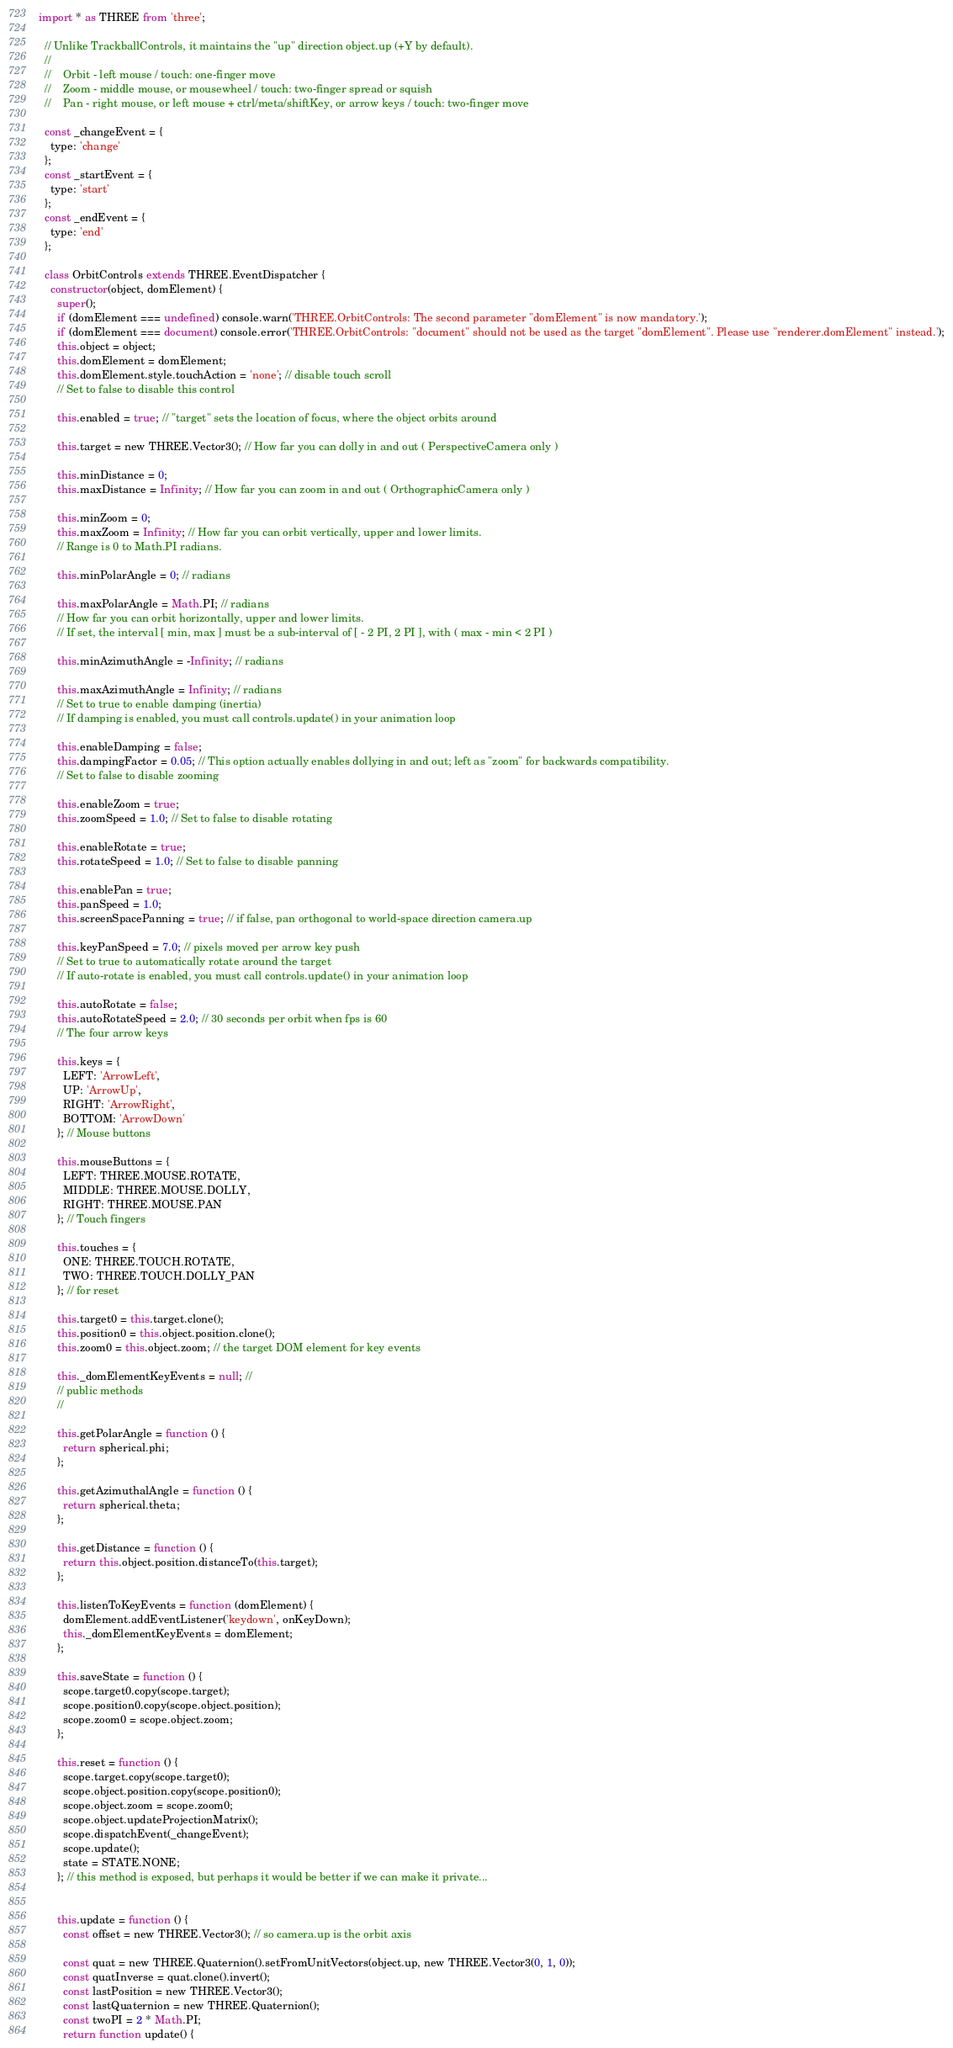Convert code to text. <code><loc_0><loc_0><loc_500><loc_500><_JavaScript_>import * as THREE from 'three';

  // Unlike TrackballControls, it maintains the "up" direction object.up (+Y by default).
  //
  //    Orbit - left mouse / touch: one-finger move
  //    Zoom - middle mouse, or mousewheel / touch: two-finger spread or squish
  //    Pan - right mouse, or left mouse + ctrl/meta/shiftKey, or arrow keys / touch: two-finger move
  
  const _changeEvent = {
    type: 'change'
  };
  const _startEvent = {
    type: 'start'
  };
  const _endEvent = {
    type: 'end'
  };
  
  class OrbitControls extends THREE.EventDispatcher {
    constructor(object, domElement) {
      super();
      if (domElement === undefined) console.warn('THREE.OrbitControls: The second parameter "domElement" is now mandatory.');
      if (domElement === document) console.error('THREE.OrbitControls: "document" should not be used as the target "domElement". Please use "renderer.domElement" instead.');
      this.object = object;
      this.domElement = domElement;
      this.domElement.style.touchAction = 'none'; // disable touch scroll
      // Set to false to disable this control
  
      this.enabled = true; // "target" sets the location of focus, where the object orbits around
  
      this.target = new THREE.Vector3(); // How far you can dolly in and out ( PerspectiveCamera only )
  
      this.minDistance = 0;
      this.maxDistance = Infinity; // How far you can zoom in and out ( OrthographicCamera only )
  
      this.minZoom = 0;
      this.maxZoom = Infinity; // How far you can orbit vertically, upper and lower limits.
      // Range is 0 to Math.PI radians.
  
      this.minPolarAngle = 0; // radians
  
      this.maxPolarAngle = Math.PI; // radians
      // How far you can orbit horizontally, upper and lower limits.
      // If set, the interval [ min, max ] must be a sub-interval of [ - 2 PI, 2 PI ], with ( max - min < 2 PI )
  
      this.minAzimuthAngle = -Infinity; // radians
  
      this.maxAzimuthAngle = Infinity; // radians
      // Set to true to enable damping (inertia)
      // If damping is enabled, you must call controls.update() in your animation loop
  
      this.enableDamping = false;
      this.dampingFactor = 0.05; // This option actually enables dollying in and out; left as "zoom" for backwards compatibility.
      // Set to false to disable zooming
  
      this.enableZoom = true;
      this.zoomSpeed = 1.0; // Set to false to disable rotating
  
      this.enableRotate = true;
      this.rotateSpeed = 1.0; // Set to false to disable panning
  
      this.enablePan = true;
      this.panSpeed = 1.0;
      this.screenSpacePanning = true; // if false, pan orthogonal to world-space direction camera.up
  
      this.keyPanSpeed = 7.0; // pixels moved per arrow key push
      // Set to true to automatically rotate around the target
      // If auto-rotate is enabled, you must call controls.update() in your animation loop
  
      this.autoRotate = false;
      this.autoRotateSpeed = 2.0; // 30 seconds per orbit when fps is 60
      // The four arrow keys
  
      this.keys = {
        LEFT: 'ArrowLeft',
        UP: 'ArrowUp',
        RIGHT: 'ArrowRight',
        BOTTOM: 'ArrowDown'
      }; // Mouse buttons
  
      this.mouseButtons = {
        LEFT: THREE.MOUSE.ROTATE,
        MIDDLE: THREE.MOUSE.DOLLY,
        RIGHT: THREE.MOUSE.PAN
      }; // Touch fingers
  
      this.touches = {
        ONE: THREE.TOUCH.ROTATE,
        TWO: THREE.TOUCH.DOLLY_PAN
      }; // for reset
  
      this.target0 = this.target.clone();
      this.position0 = this.object.position.clone();
      this.zoom0 = this.object.zoom; // the target DOM element for key events
  
      this._domElementKeyEvents = null; //
      // public methods
      //
  
      this.getPolarAngle = function () {
        return spherical.phi;
      };
  
      this.getAzimuthalAngle = function () {
        return spherical.theta;
      };
  
      this.getDistance = function () {
        return this.object.position.distanceTo(this.target);
      };
  
      this.listenToKeyEvents = function (domElement) {
        domElement.addEventListener('keydown', onKeyDown);
        this._domElementKeyEvents = domElement;
      };
  
      this.saveState = function () {
        scope.target0.copy(scope.target);
        scope.position0.copy(scope.object.position);
        scope.zoom0 = scope.object.zoom;
      };
  
      this.reset = function () {
        scope.target.copy(scope.target0);
        scope.object.position.copy(scope.position0);
        scope.object.zoom = scope.zoom0;
        scope.object.updateProjectionMatrix();
        scope.dispatchEvent(_changeEvent);
        scope.update();
        state = STATE.NONE;
      }; // this method is exposed, but perhaps it would be better if we can make it private...
  
  
      this.update = function () {
        const offset = new THREE.Vector3(); // so camera.up is the orbit axis
  
        const quat = new THREE.Quaternion().setFromUnitVectors(object.up, new THREE.Vector3(0, 1, 0));
        const quatInverse = quat.clone().invert();
        const lastPosition = new THREE.Vector3();
        const lastQuaternion = new THREE.Quaternion();
        const twoPI = 2 * Math.PI;
        return function update() {</code> 